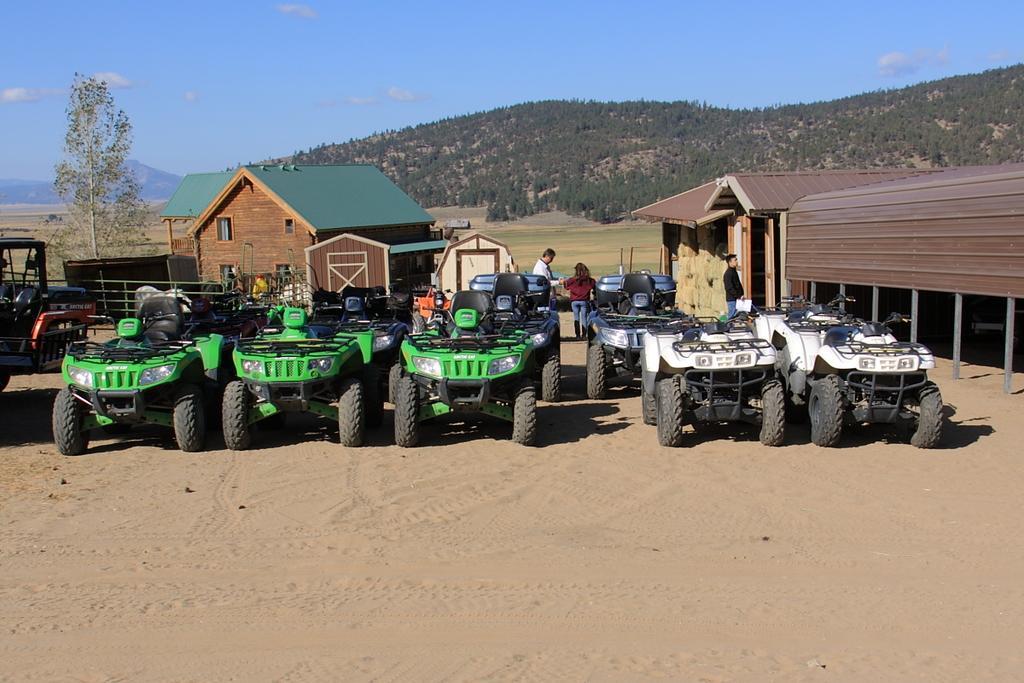How would you summarize this image in a sentence or two? In the picture I can see vehicles, houses, trees and some other objects. I can also see people standing on the ground. In the background I can see the sky. 